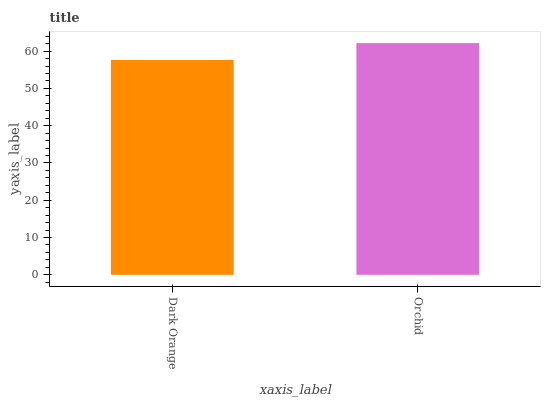Is Dark Orange the minimum?
Answer yes or no. Yes. Is Orchid the maximum?
Answer yes or no. Yes. Is Orchid the minimum?
Answer yes or no. No. Is Orchid greater than Dark Orange?
Answer yes or no. Yes. Is Dark Orange less than Orchid?
Answer yes or no. Yes. Is Dark Orange greater than Orchid?
Answer yes or no. No. Is Orchid less than Dark Orange?
Answer yes or no. No. Is Orchid the high median?
Answer yes or no. Yes. Is Dark Orange the low median?
Answer yes or no. Yes. Is Dark Orange the high median?
Answer yes or no. No. Is Orchid the low median?
Answer yes or no. No. 